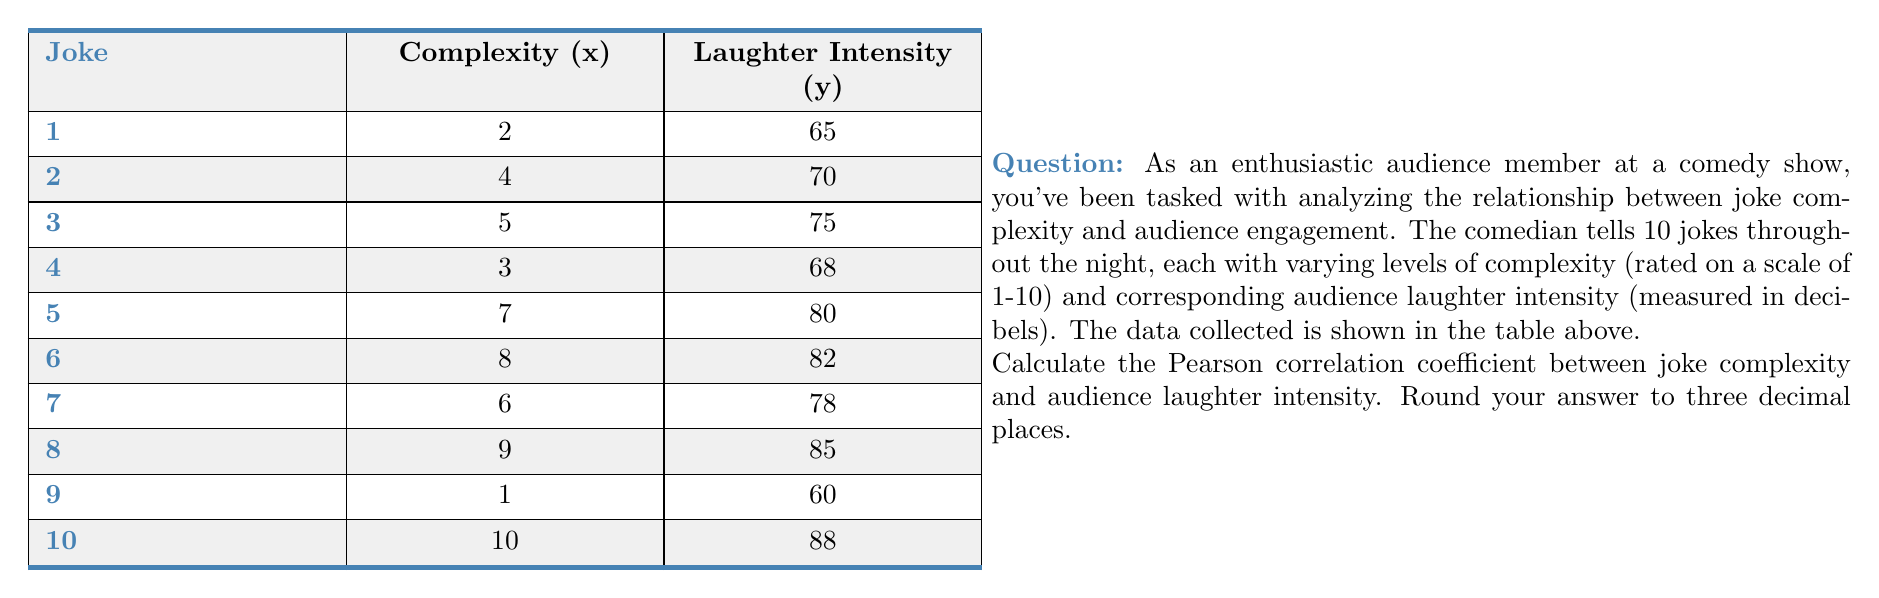What is the answer to this math problem? To calculate the Pearson correlation coefficient, we'll follow these steps:

1) First, we need to calculate the means of x (complexity) and y (laughter intensity):

   $\bar{x} = \frac{2+4+5+3+7+8+6+9+1+10}{10} = 5.5$
   $\bar{y} = \frac{65+70+75+68+80+82+78+85+60+88}{10} = 75.1$

2) Next, we calculate the differences from the mean for each x and y value:

   $(x_i - \bar{x})$ and $(y_i - \bar{y})$

3) We square these differences and multiply them together:

   $(x_i - \bar{x})^2$, $(y_i - \bar{y})^2$, and $(x_i - \bar{x})(y_i - \bar{y})$

4) Sum up all these values:

   $\sum(x_i - \bar{x})^2 = 88.5$
   $\sum(y_i - \bar{y})^2 = 694.9$
   $\sum(x_i - \bar{x})(y_i - \bar{y}) = 234.5$

5) Now we can apply the formula for Pearson correlation coefficient:

   $$r = \frac{\sum(x_i - \bar{x})(y_i - \bar{y})}{\sqrt{\sum(x_i - \bar{x})^2 \sum(y_i - \bar{y})^2}}$$

6) Plugging in our values:

   $$r = \frac{234.5}{\sqrt{88.5 \times 694.9}} = \frac{234.5}{\sqrt{61498.65}} = \frac{234.5}{247.987}$$

7) Calculate and round to three decimal places:

   $r \approx 0.946$
Answer: 0.946 